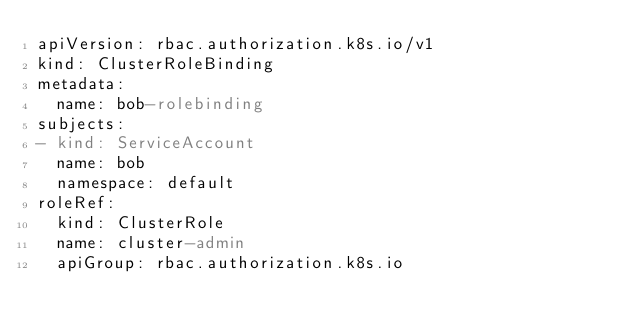<code> <loc_0><loc_0><loc_500><loc_500><_YAML_>apiVersion: rbac.authorization.k8s.io/v1
kind: ClusterRoleBinding
metadata:
  name: bob-rolebinding
subjects:
- kind: ServiceAccount
  name: bob
  namespace: default
roleRef:
  kind: ClusterRole
  name: cluster-admin
  apiGroup: rbac.authorization.k8s.io</code> 